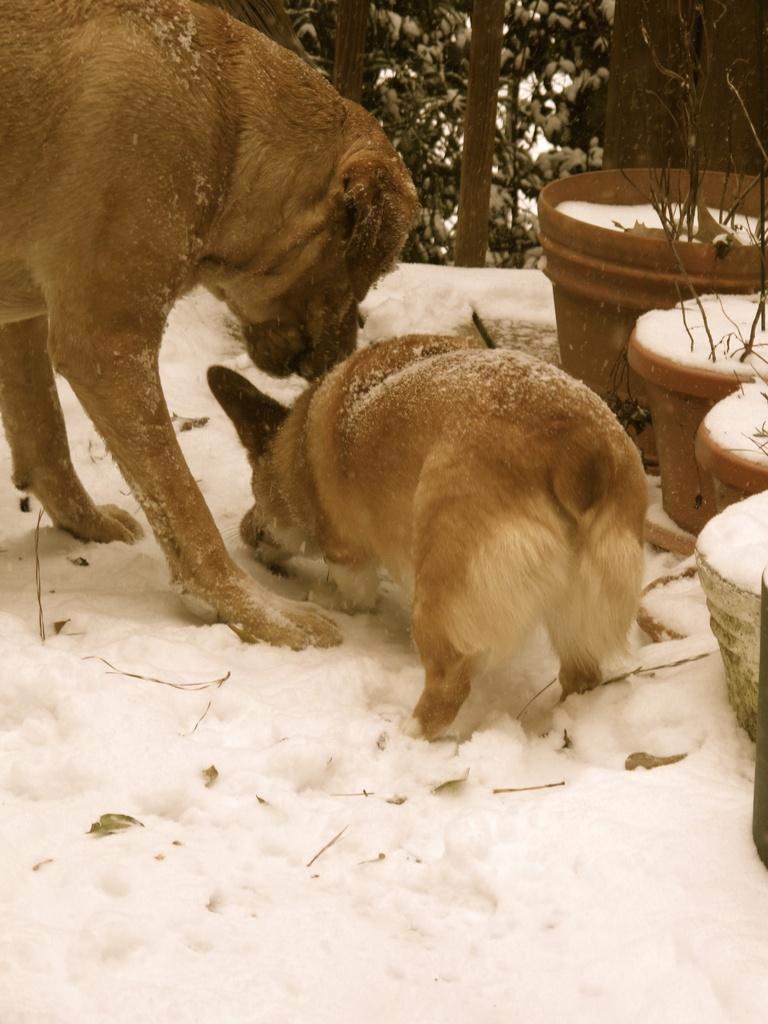What type of animal can be seen in the image? There is a dog and a puppy in the image. What is the ground covered with in the image? There is snow on the ground in the image. What objects are present for planting purposes? There are flower pots in the image. What type of plant is visible in the image? There is a green plant in the image. What level of expertise does the dog have in performing medical procedures in the image? There is no indication in the image that the dog is performing any medical procedures or has any level of expertise in such tasks. 